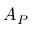<formula> <loc_0><loc_0><loc_500><loc_500>A _ { P }</formula> 